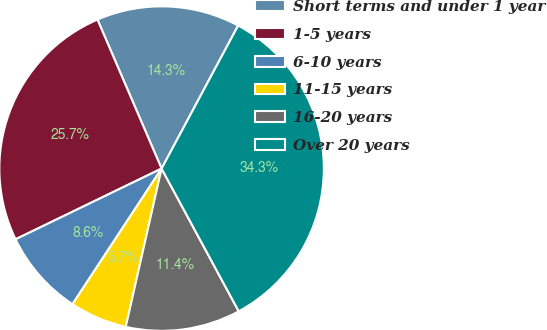Convert chart. <chart><loc_0><loc_0><loc_500><loc_500><pie_chart><fcel>Short terms and under 1 year<fcel>1-5 years<fcel>6-10 years<fcel>11-15 years<fcel>16-20 years<fcel>Over 20 years<nl><fcel>14.29%<fcel>25.71%<fcel>8.57%<fcel>5.71%<fcel>11.43%<fcel>34.29%<nl></chart> 